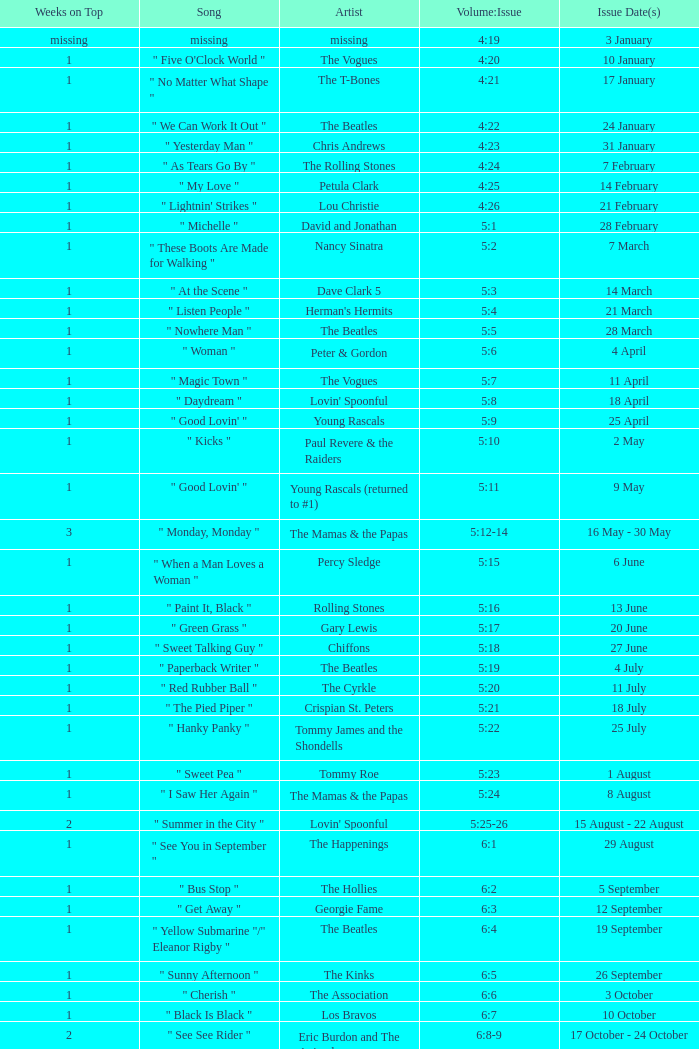With an issue date(s) of 12 September, what is in the column for Weeks on Top? 1.0. 